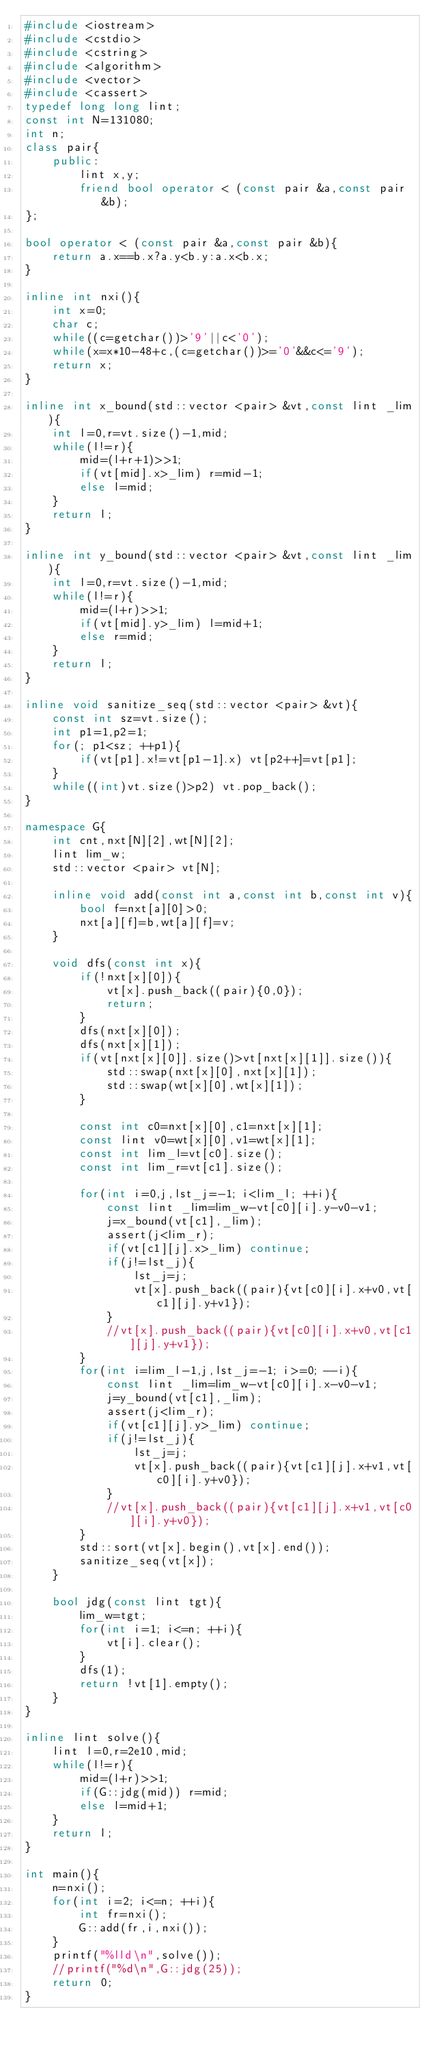<code> <loc_0><loc_0><loc_500><loc_500><_C++_>#include <iostream>
#include <cstdio>
#include <cstring>
#include <algorithm>
#include <vector>
#include <cassert>
typedef long long lint;
const int N=131080;
int n;
class pair{
	public:
		lint x,y;
		friend bool operator < (const pair &a,const pair &b);
};

bool operator < (const pair &a,const pair &b){
	return a.x==b.x?a.y<b.y:a.x<b.x;
}

inline int nxi(){
	int x=0;
	char c;
	while((c=getchar())>'9'||c<'0');
	while(x=x*10-48+c,(c=getchar())>='0'&&c<='9');
	return x;
}

inline int x_bound(std::vector <pair> &vt,const lint _lim){
	int l=0,r=vt.size()-1,mid;
	while(l!=r){
		mid=(l+r+1)>>1;
		if(vt[mid].x>_lim) r=mid-1;
		else l=mid;
	}
	return l;
}

inline int y_bound(std::vector <pair> &vt,const lint _lim){
	int l=0,r=vt.size()-1,mid;
	while(l!=r){
		mid=(l+r)>>1;
		if(vt[mid].y>_lim) l=mid+1;
		else r=mid;
	}
	return l;
}

inline void sanitize_seq(std::vector <pair> &vt){
	const int sz=vt.size();
	int p1=1,p2=1;
	for(; p1<sz; ++p1){
		if(vt[p1].x!=vt[p1-1].x) vt[p2++]=vt[p1];
	}
	while((int)vt.size()>p2) vt.pop_back();
}

namespace G{
	int cnt,nxt[N][2],wt[N][2];
	lint lim_w;
	std::vector <pair> vt[N];

	inline void add(const int a,const int b,const int v){
		bool f=nxt[a][0]>0;
		nxt[a][f]=b,wt[a][f]=v;
	}

	void dfs(const int x){
		if(!nxt[x][0]){
			vt[x].push_back((pair){0,0});
			return;
		}
		dfs(nxt[x][0]);
		dfs(nxt[x][1]);
		if(vt[nxt[x][0]].size()>vt[nxt[x][1]].size()){
			std::swap(nxt[x][0],nxt[x][1]);
			std::swap(wt[x][0],wt[x][1]);
		}

		const int c0=nxt[x][0],c1=nxt[x][1];
		const lint v0=wt[x][0],v1=wt[x][1];
		const int lim_l=vt[c0].size();
		const int lim_r=vt[c1].size();

		for(int i=0,j,lst_j=-1; i<lim_l; ++i){
			const lint _lim=lim_w-vt[c0][i].y-v0-v1;
			j=x_bound(vt[c1],_lim);
			assert(j<lim_r);
			if(vt[c1][j].x>_lim) continue;
			if(j!=lst_j){
				lst_j=j;
				vt[x].push_back((pair){vt[c0][i].x+v0,vt[c1][j].y+v1});
			}
			//vt[x].push_back((pair){vt[c0][i].x+v0,vt[c1][j].y+v1});
		}
		for(int i=lim_l-1,j,lst_j=-1; i>=0; --i){
			const lint _lim=lim_w-vt[c0][i].x-v0-v1;
			j=y_bound(vt[c1],_lim);
			assert(j<lim_r);
			if(vt[c1][j].y>_lim) continue;
			if(j!=lst_j){
				lst_j=j;
				vt[x].push_back((pair){vt[c1][j].x+v1,vt[c0][i].y+v0});
			}
			//vt[x].push_back((pair){vt[c1][j].x+v1,vt[c0][i].y+v0});
		}
		std::sort(vt[x].begin(),vt[x].end());
		sanitize_seq(vt[x]);
	}

	bool jdg(const lint tgt){
		lim_w=tgt;
		for(int i=1; i<=n; ++i){
			vt[i].clear();
		}
		dfs(1);
		return !vt[1].empty();
	}
}

inline lint solve(){
	lint l=0,r=2e10,mid;
	while(l!=r){
		mid=(l+r)>>1;
		if(G::jdg(mid)) r=mid;
		else l=mid+1;
	}
	return l;
}

int main(){
	n=nxi();
	for(int i=2; i<=n; ++i){
		int fr=nxi();
		G::add(fr,i,nxi());
	}
	printf("%lld\n",solve());
	//printf("%d\n",G::jdg(25));
	return 0;
}</code> 